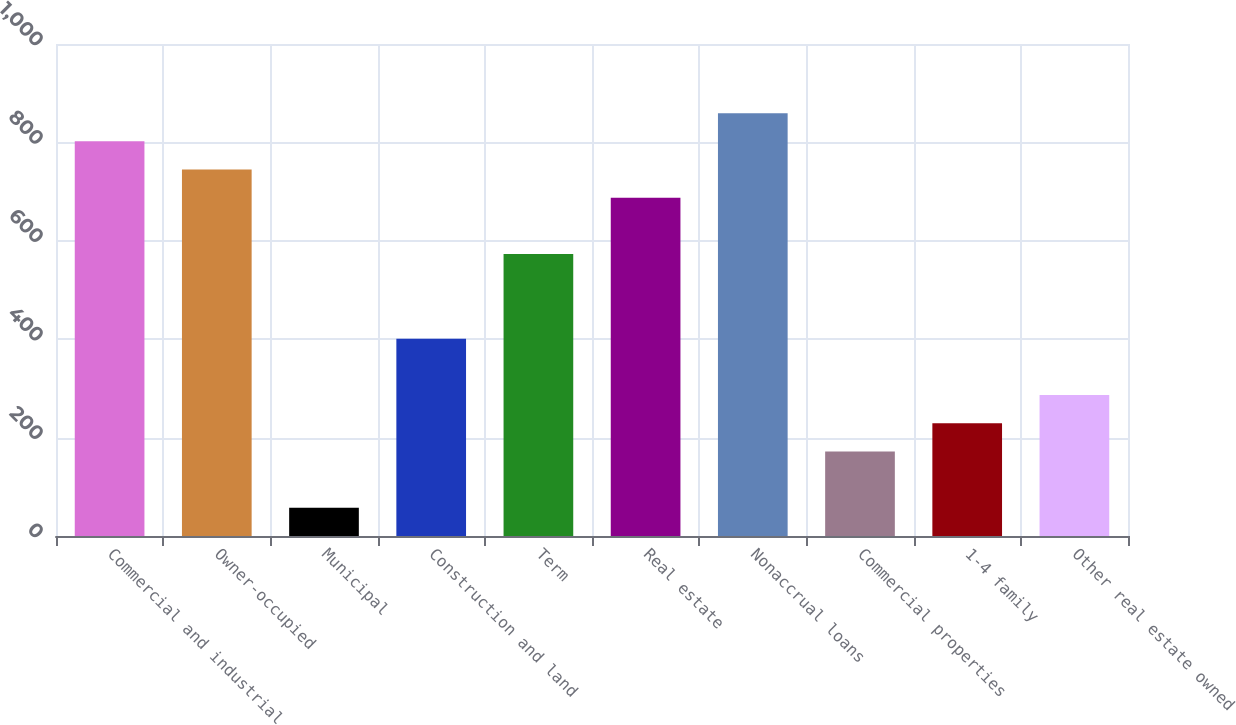Convert chart to OTSL. <chart><loc_0><loc_0><loc_500><loc_500><bar_chart><fcel>Commercial and industrial<fcel>Owner-occupied<fcel>Municipal<fcel>Construction and land<fcel>Term<fcel>Real estate<fcel>Nonaccrual loans<fcel>Commercial properties<fcel>1-4 family<fcel>Other real estate owned<nl><fcel>802.14<fcel>744.85<fcel>57.37<fcel>401.11<fcel>572.98<fcel>687.56<fcel>859.43<fcel>171.95<fcel>229.24<fcel>286.53<nl></chart> 